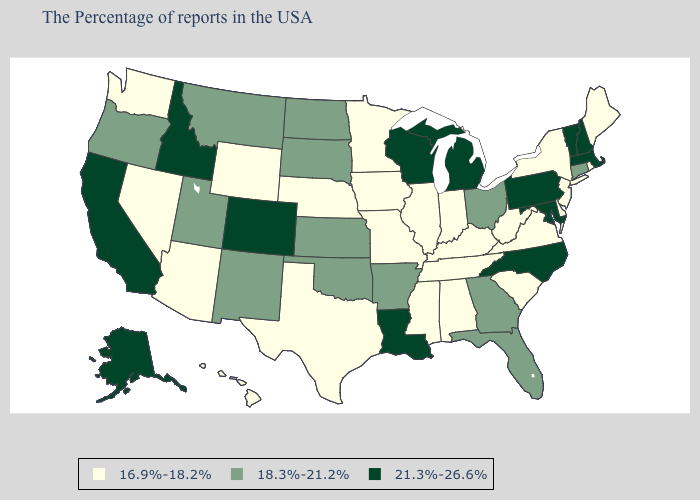What is the value of Kansas?
Answer briefly. 18.3%-21.2%. Does South Dakota have the same value as Alaska?
Be succinct. No. Name the states that have a value in the range 16.9%-18.2%?
Quick response, please. Maine, Rhode Island, New York, New Jersey, Delaware, Virginia, South Carolina, West Virginia, Kentucky, Indiana, Alabama, Tennessee, Illinois, Mississippi, Missouri, Minnesota, Iowa, Nebraska, Texas, Wyoming, Arizona, Nevada, Washington, Hawaii. Name the states that have a value in the range 18.3%-21.2%?
Quick response, please. Connecticut, Ohio, Florida, Georgia, Arkansas, Kansas, Oklahoma, South Dakota, North Dakota, New Mexico, Utah, Montana, Oregon. What is the value of Missouri?
Keep it brief. 16.9%-18.2%. What is the value of Arkansas?
Write a very short answer. 18.3%-21.2%. What is the value of Florida?
Write a very short answer. 18.3%-21.2%. Among the states that border Colorado , does Nebraska have the highest value?
Concise answer only. No. Does Idaho have the highest value in the USA?
Quick response, please. Yes. Name the states that have a value in the range 18.3%-21.2%?
Quick response, please. Connecticut, Ohio, Florida, Georgia, Arkansas, Kansas, Oklahoma, South Dakota, North Dakota, New Mexico, Utah, Montana, Oregon. Among the states that border Colorado , which have the lowest value?
Be succinct. Nebraska, Wyoming, Arizona. What is the lowest value in states that border Rhode Island?
Give a very brief answer. 18.3%-21.2%. What is the value of Iowa?
Be succinct. 16.9%-18.2%. Among the states that border Virginia , does North Carolina have the highest value?
Give a very brief answer. Yes. Name the states that have a value in the range 21.3%-26.6%?
Concise answer only. Massachusetts, New Hampshire, Vermont, Maryland, Pennsylvania, North Carolina, Michigan, Wisconsin, Louisiana, Colorado, Idaho, California, Alaska. 